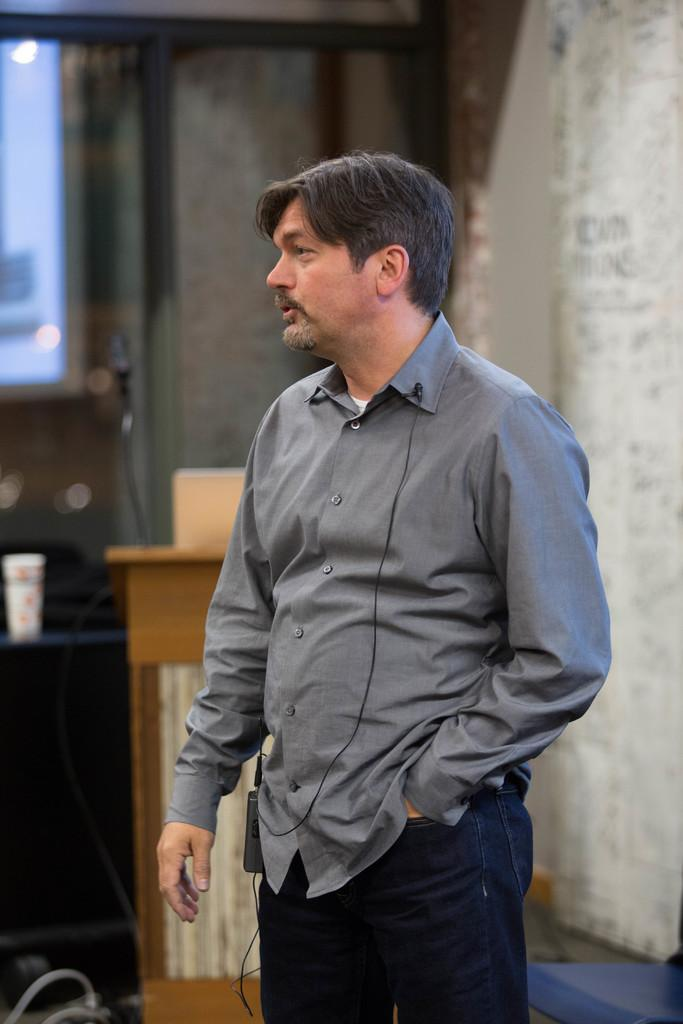What is the main subject of the image? There is a person standing in the image. What can be seen in the background of the image? There is a wall in the background of the image. What type of architectural feature is present in the image? There is a glass window in the image. What object might be used for presentations or speeches in the image? There is a podium in the image. What type of waves can be seen crashing against the shore in the image? There are no waves or shoreline present in the image; it features a person, a wall, a glass window, and a podium. 